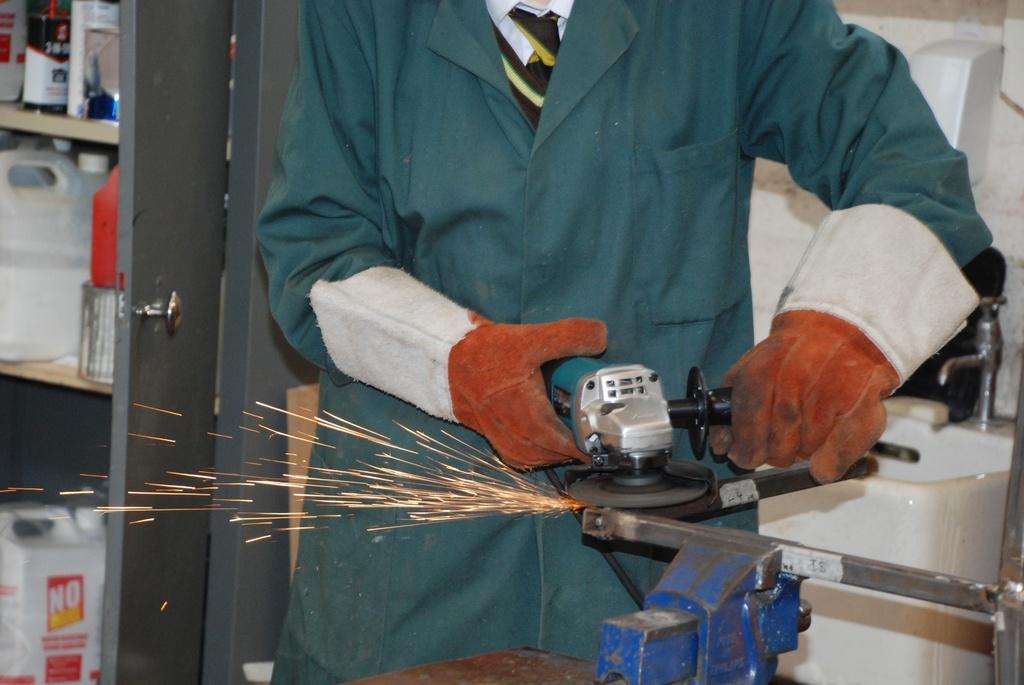In one or two sentences, can you explain what this image depicts? In this image there is a person holding an object is sharpening the edges of a metal rod, behind him there is a tap on the sink and there are a few cans on the shelves inside a door. 